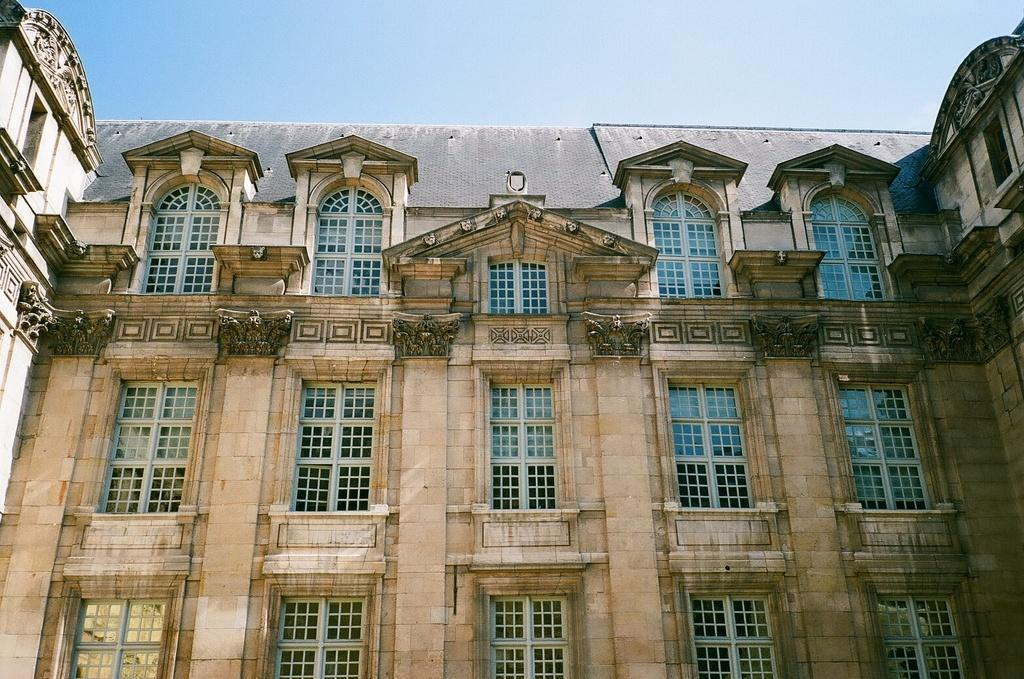What type of structure is present in the image? There is a building in the image. What feature of the building is mentioned in the facts? The building has many windows. What is visible at the top of the image? The sky is visible at the top of the image. What type of grass is growing comfortably on the rock in the image? There is no grass, comfort, or rock present in the image; it only features a building with many windows and the sky visible at the top. 